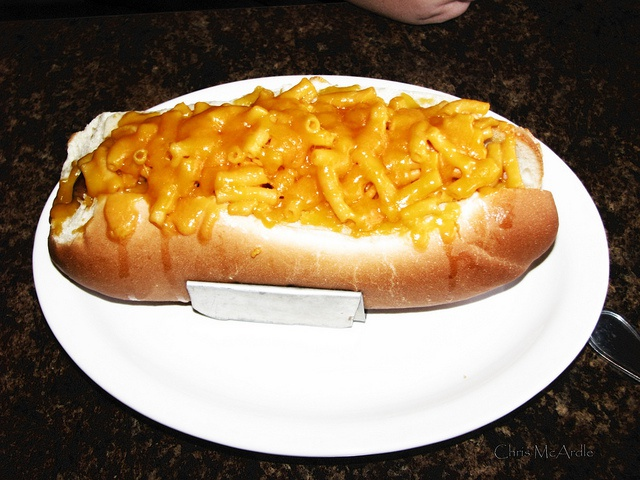Describe the objects in this image and their specific colors. I can see dining table in black, white, and orange tones, hot dog in black, orange, and brown tones, and spoon in black, gray, and darkgray tones in this image. 